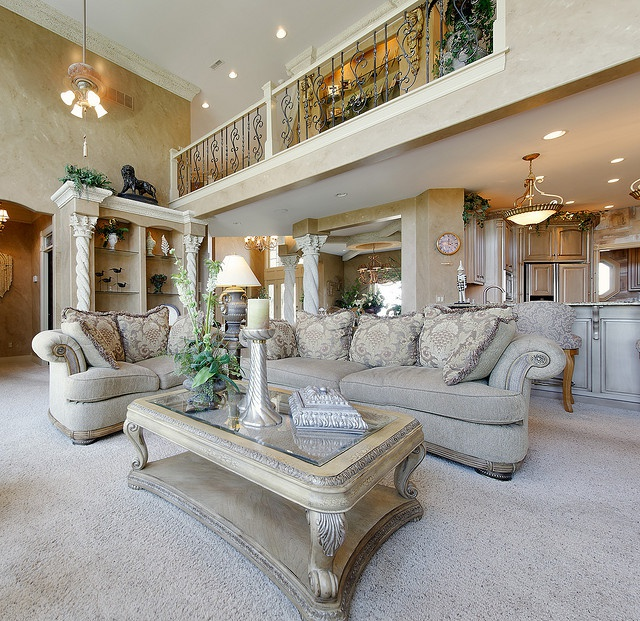Describe the objects in this image and their specific colors. I can see couch in darkgray, gray, and lightgray tones, couch in darkgray, lightgray, and gray tones, potted plant in darkgray, gray, lightgray, and green tones, chair in darkgray, gray, and maroon tones, and potted plant in darkgray, white, gray, and black tones in this image. 